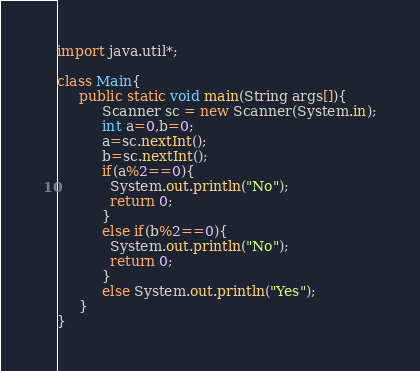<code> <loc_0><loc_0><loc_500><loc_500><_Java_>import java.util*;
 
class Main{
     public static void main(String args[]){
          Scanner sc = new Scanner(System.in);
          int a=0,b=0;
          a=sc.nextInt();
          b=sc.nextInt();
          if(a%2==0){
            System.out.println("No");
            return 0;
          }
          else if(b%2==0){
            System.out.println("No");
            return 0;
          }
          else System.out.println("Yes");
     }
}</code> 